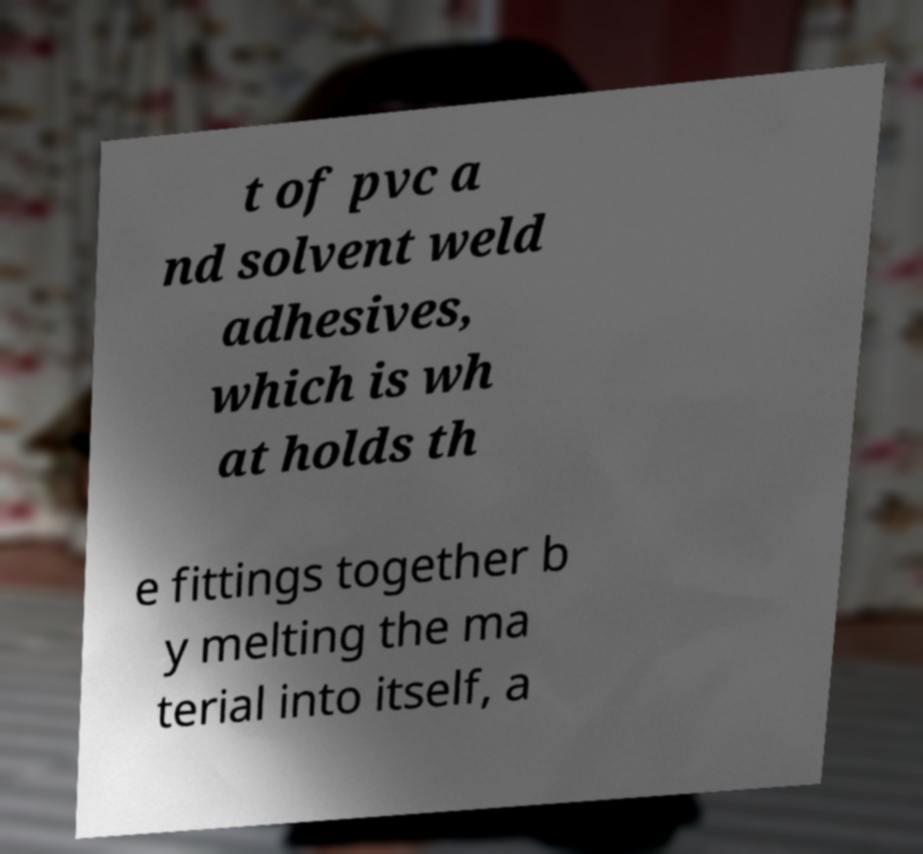What messages or text are displayed in this image? I need them in a readable, typed format. t of pvc a nd solvent weld adhesives, which is wh at holds th e fittings together b y melting the ma terial into itself, a 